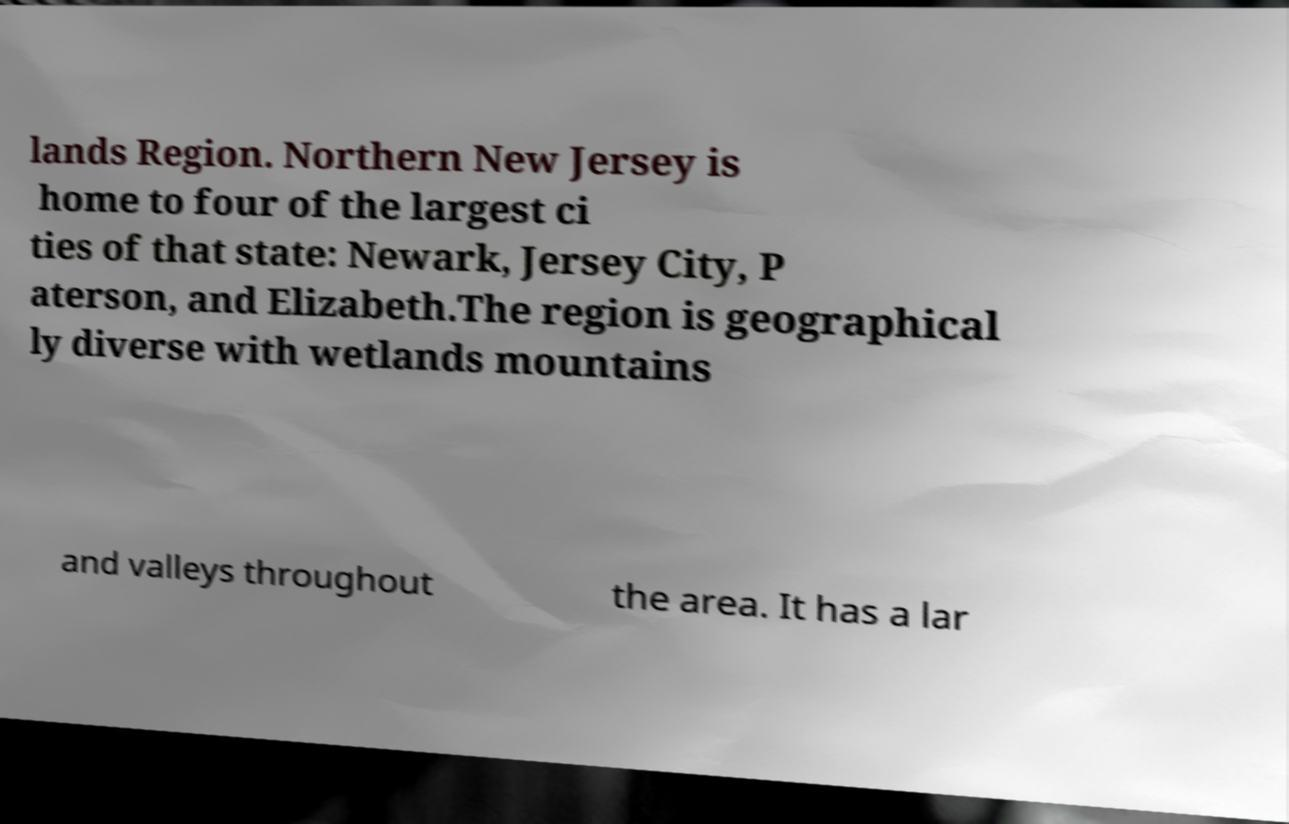There's text embedded in this image that I need extracted. Can you transcribe it verbatim? lands Region. Northern New Jersey is home to four of the largest ci ties of that state: Newark, Jersey City, P aterson, and Elizabeth.The region is geographical ly diverse with wetlands mountains and valleys throughout the area. It has a lar 